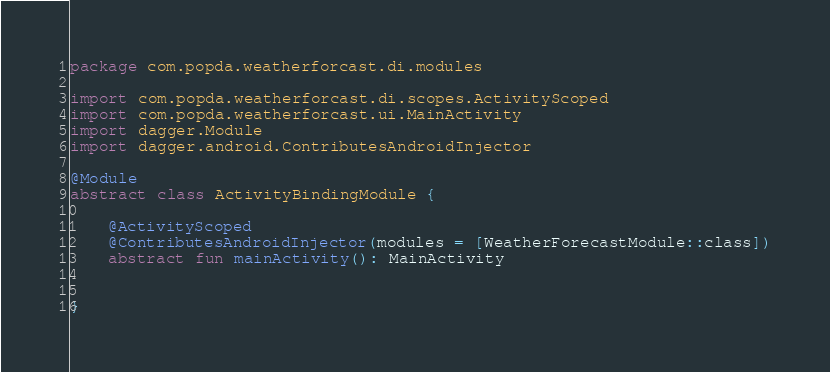<code> <loc_0><loc_0><loc_500><loc_500><_Kotlin_>package com.popda.weatherforcast.di.modules

import com.popda.weatherforcast.di.scopes.ActivityScoped
import com.popda.weatherforcast.ui.MainActivity
import dagger.Module
import dagger.android.ContributesAndroidInjector

@Module
abstract class ActivityBindingModule {

    @ActivityScoped
    @ContributesAndroidInjector(modules = [WeatherForecastModule::class])
    abstract fun mainActivity(): MainActivity


}</code> 